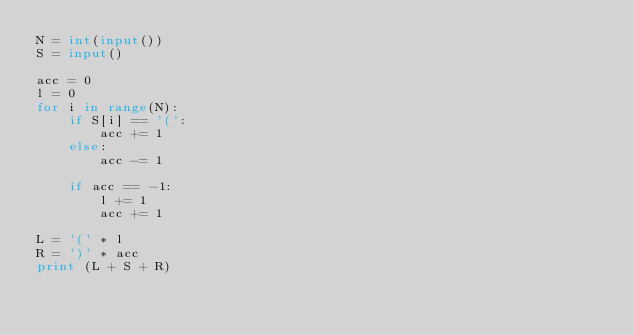<code> <loc_0><loc_0><loc_500><loc_500><_Python_>N = int(input())
S = input()

acc = 0
l = 0
for i in range(N):
    if S[i] == '(':
        acc += 1
    else:
        acc -= 1

    if acc == -1:
        l += 1
        acc += 1

L = '(' * l
R = ')' * acc
print (L + S + R)</code> 